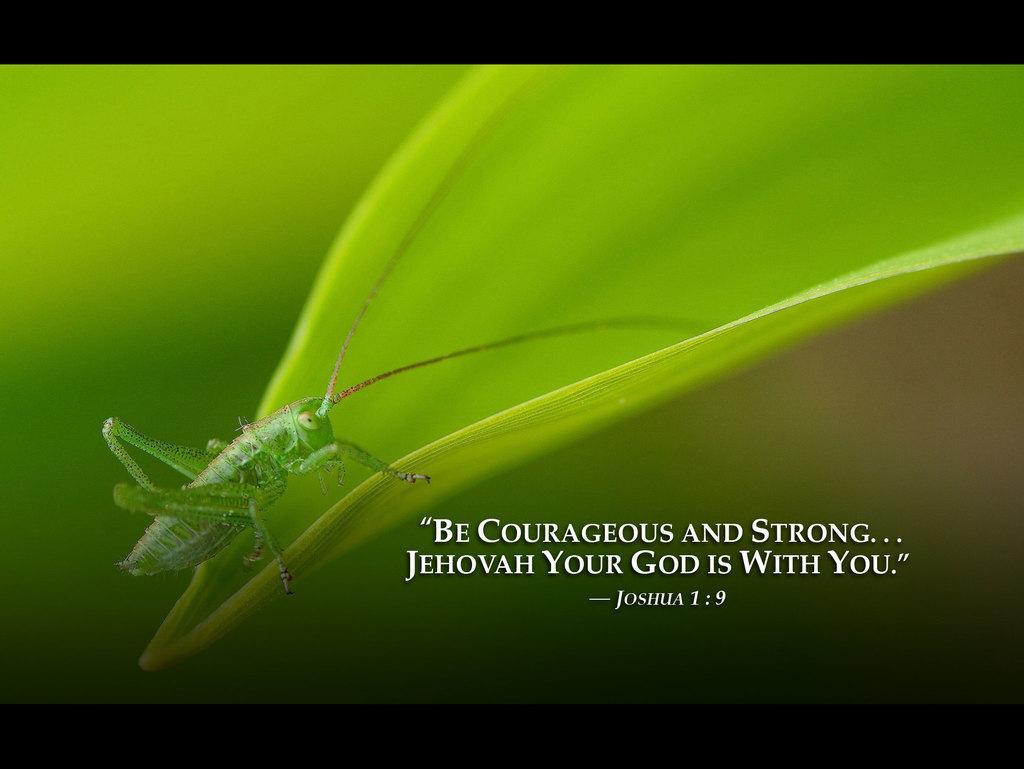Could you give a brief overview of what you see in this image? In the picture I can see a green color grasshopper on the green color leaf. The background of the image is blurred. Here I can see some edited text at the bottom of the image. 